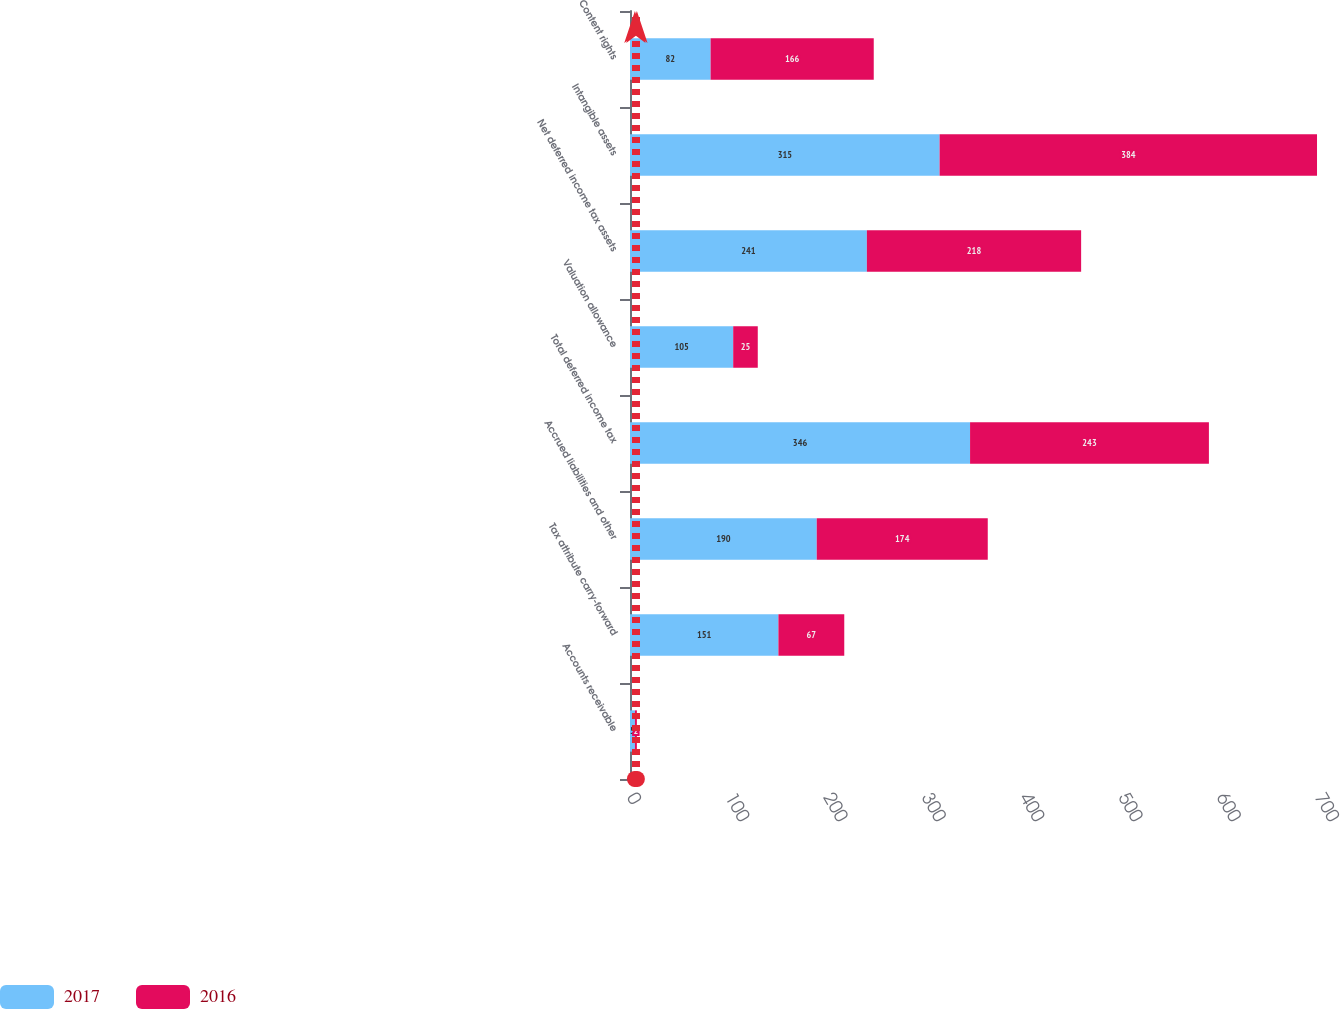Convert chart to OTSL. <chart><loc_0><loc_0><loc_500><loc_500><stacked_bar_chart><ecel><fcel>Accounts receivable<fcel>Tax attribute carry-forward<fcel>Accrued liabilities and other<fcel>Total deferred income tax<fcel>Valuation allowance<fcel>Net deferred income tax assets<fcel>Intangible assets<fcel>Content rights<nl><fcel>2017<fcel>5<fcel>151<fcel>190<fcel>346<fcel>105<fcel>241<fcel>315<fcel>82<nl><fcel>2016<fcel>2<fcel>67<fcel>174<fcel>243<fcel>25<fcel>218<fcel>384<fcel>166<nl></chart> 